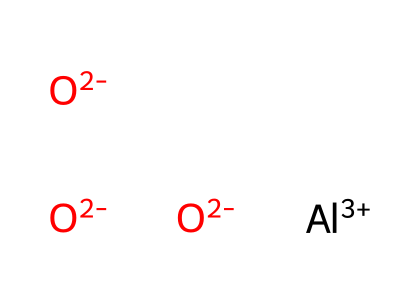What is the molecular formula of the compound? The compound consists of 1 aluminum atom and 3 oxygen atoms, represented as AlO3.
Answer: AlO3 How many total atoms are present in this molecule? The molecule has 4 atoms in total: 1 aluminum and 3 oxygen atoms.
Answer: 4 What is the oxidation state of aluminum in this compound? Aluminum is in the +3 oxidation state as indicated by [Al+3].
Answer: +3 What type of bonds are primarily present in this structure? The structure primarily includes ionic bonds due to the presence of charged ions, [Al+3] and [O-2].
Answer: ionic Why is aluminum oxide used in computer heat sinks? Aluminum oxide has excellent thermal conductivity and is a good insulator, making it ideal for heat dissipation in computers.
Answer: thermal conductivity Which property allows aluminum oxide to form ceramics? Its ability to form a sturdy, durable crystalline structure enables it to be classified as a ceramic material.
Answer: durability 